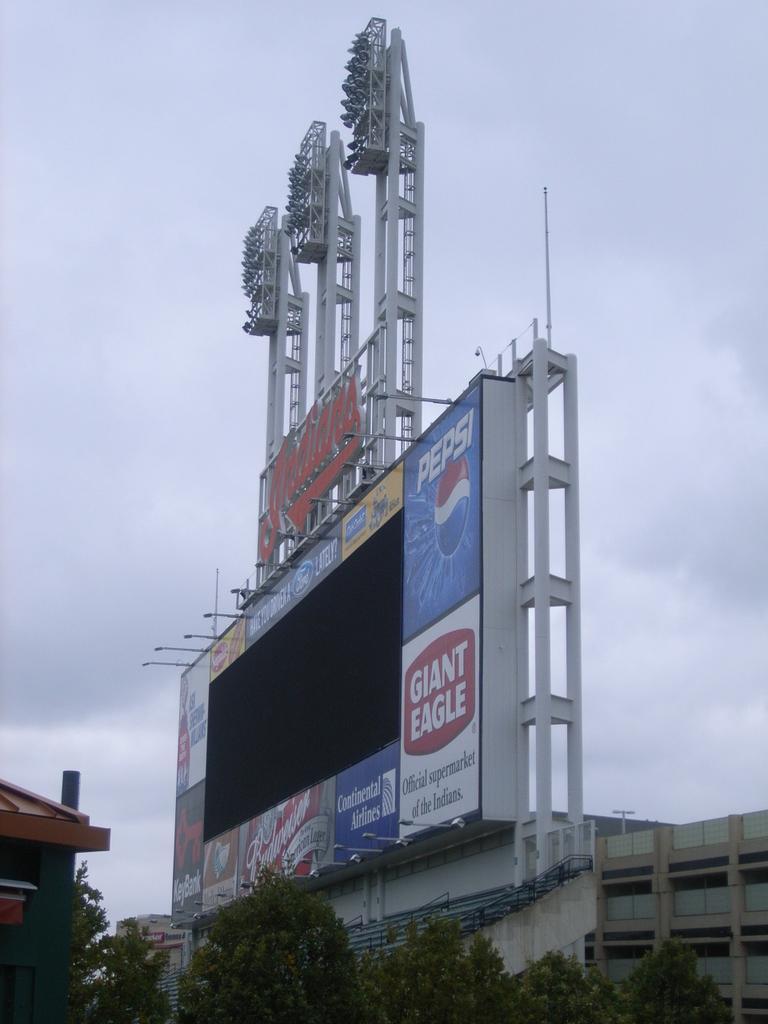Can you describe this image briefly? As we can see in the image there are buildings, trees, banner and sky. 